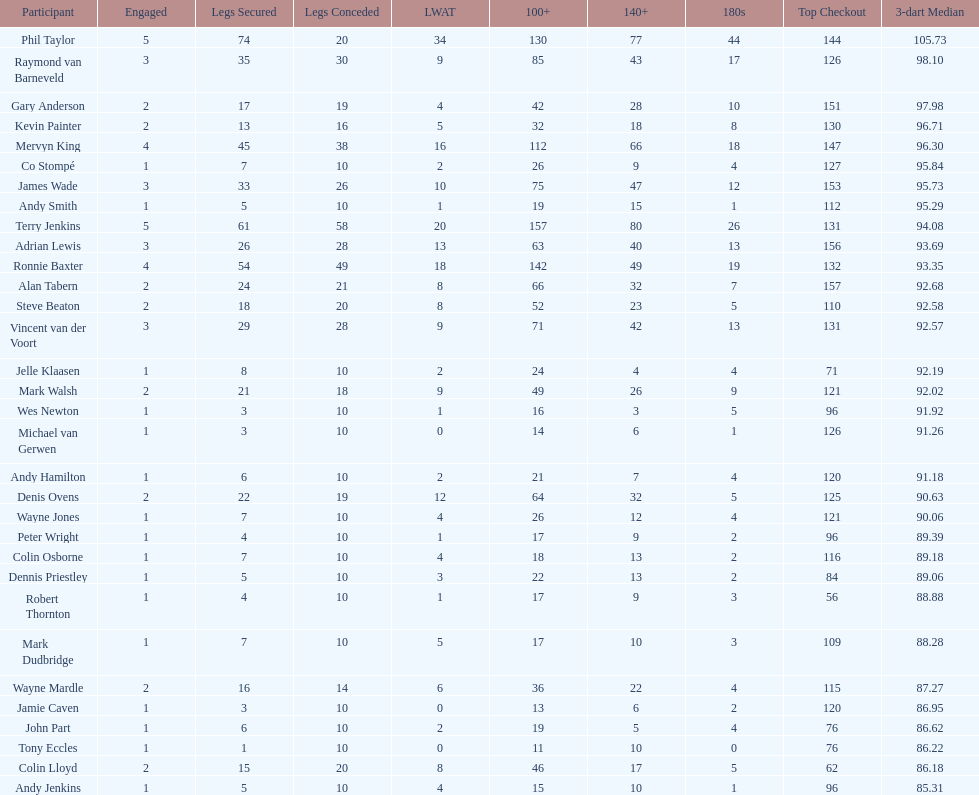How many players have a 3 dart average of more than 97? 3. 